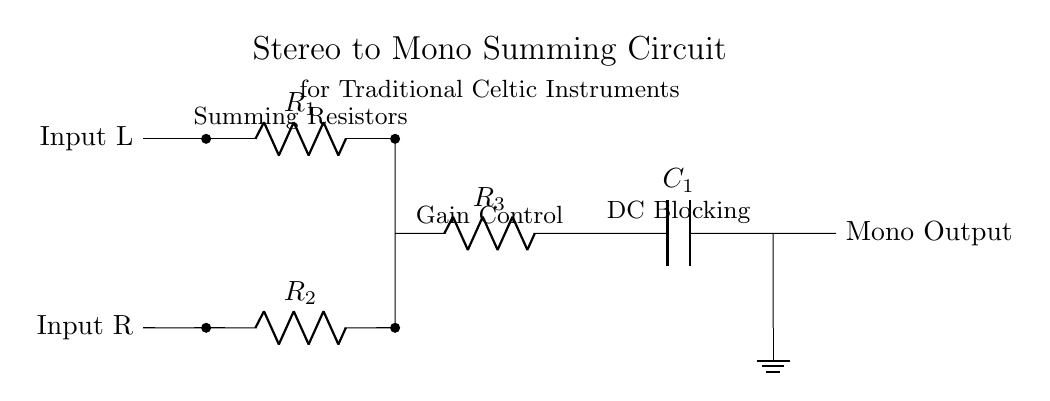What are the two inputs labeled in the circuit? The two inputs are labeled as "Input L" and "Input R". These labels indicate the left and right audio input signals for the stereo summing circuit.
Answer: Input L and Input R How many resistors are present in the summing circuit? There are three resistors present in the circuit, labeled as R1, R2, and R3. They are used for the summing process and gain control within the circuit.
Answer: Three What is the role of capacitor C1? Capacitor C1 is used for DC blocking to prevent any DC offset from reaching the output, allowing only the AC audio signal to pass through. This is crucial for maintaining audio quality.
Answer: DC blocking What is the function of the summing resistors? The summing resistors (R1 and R2) combine the two input signals into a single output signal by mixing their voltages in a defined ratio, which is essential for proper mono mixing of the two stereo channels.
Answer: Combine audio signals Which component is directly connected to the ground? The ground connection is made at the output, specifically at the bottom connection of capacitor C1, stabilizing the reference point for the circuit.
Answer: Capacitor C1 What does the output label indicate? The output label indicates where the mixed mono audio signal is available after processing through the circuit, suited for further amplification or recording.
Answer: Mono Output What is indicated by the component labeled R3? Resistor R3 is part of the gain control stage, which adjusts the overall output level of the mixed signal before it is sent to the output.
Answer: Gain Control 